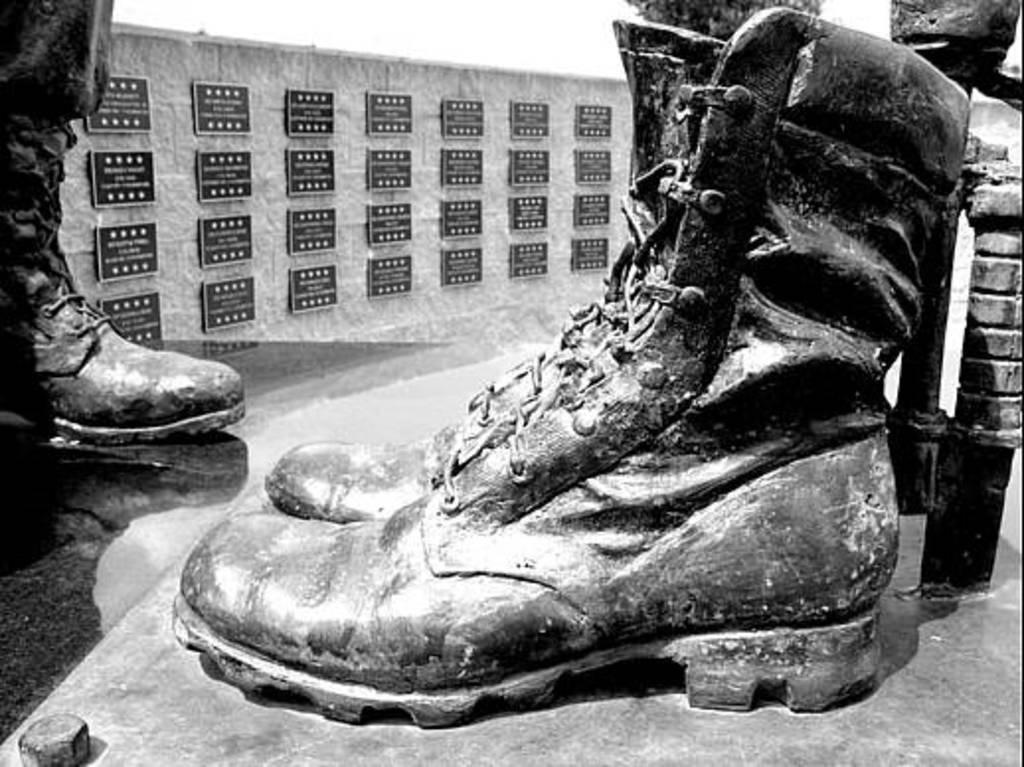In one or two sentences, can you explain what this image depicts? This is a black and white image. Here I can see the statues of shoes and a person's leg. In the background there are few frames attached to the wall. 